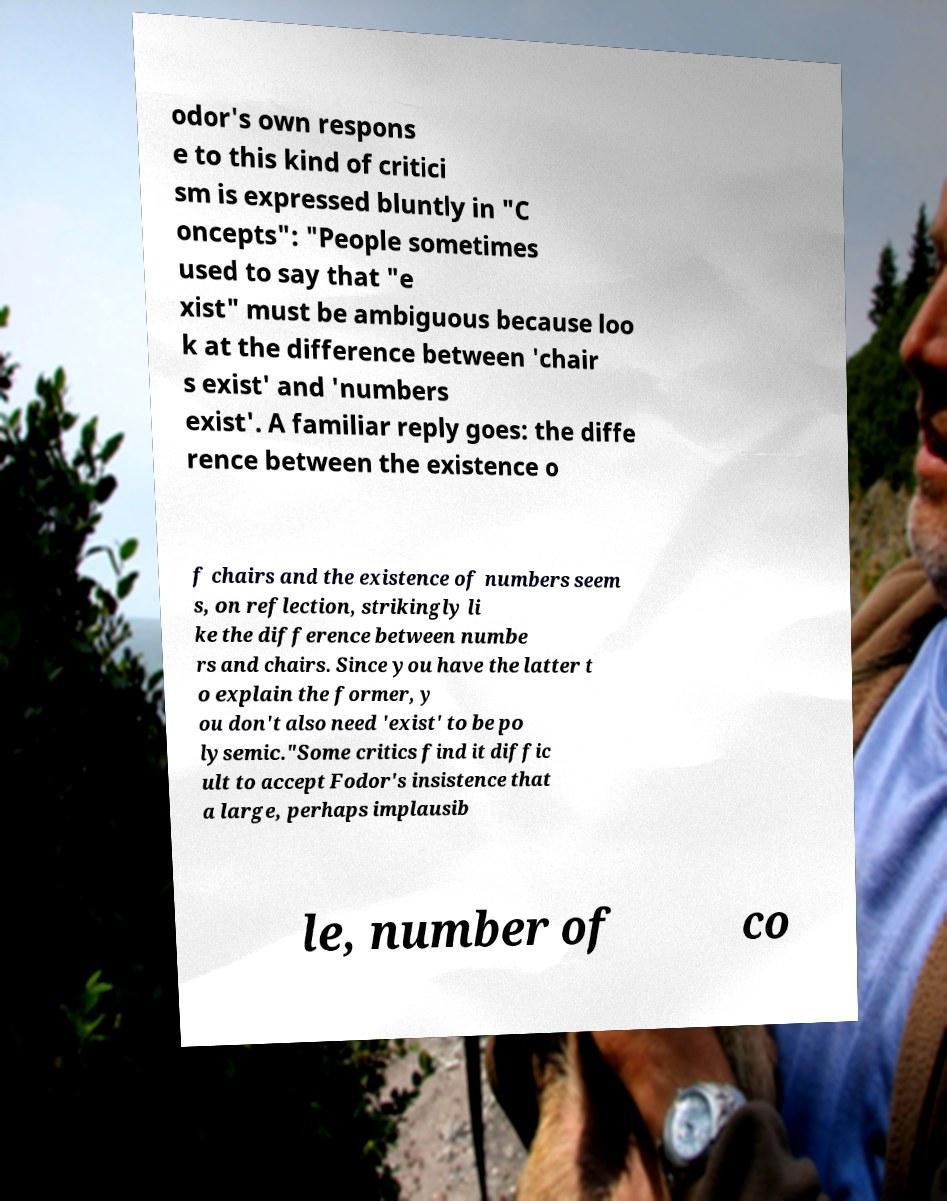Could you assist in decoding the text presented in this image and type it out clearly? odor's own respons e to this kind of critici sm is expressed bluntly in "C oncepts": "People sometimes used to say that "e xist" must be ambiguous because loo k at the difference between 'chair s exist' and 'numbers exist'. A familiar reply goes: the diffe rence between the existence o f chairs and the existence of numbers seem s, on reflection, strikingly li ke the difference between numbe rs and chairs. Since you have the latter t o explain the former, y ou don't also need 'exist' to be po lysemic."Some critics find it diffic ult to accept Fodor's insistence that a large, perhaps implausib le, number of co 